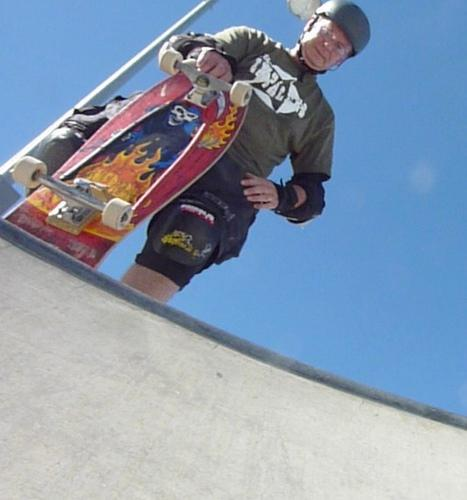Question: how many men are there?
Choices:
A. Two.
B. Three.
C. One.
D. Four.
Answer with the letter. Answer: C Question: who is there?
Choices:
A. A woman.
B. A man.
C. A teenager.
D. An elderly man.
Answer with the letter. Answer: B Question: where is the man?
Choices:
A. By the bowling alley.
B. By the pool hall.
C. By the skate park.
D. By the roller rink.
Answer with the letter. Answer: C Question: why is the man there?
Choices:
A. To ride on roller blades.
B. To ride a skateboard.
C. To ride a bike.
D. To ride a scooter.
Answer with the letter. Answer: B Question: what color is the sky?
Choices:
A. Red.
B. White.
C. Blue.
D. Grey.
Answer with the letter. Answer: C 